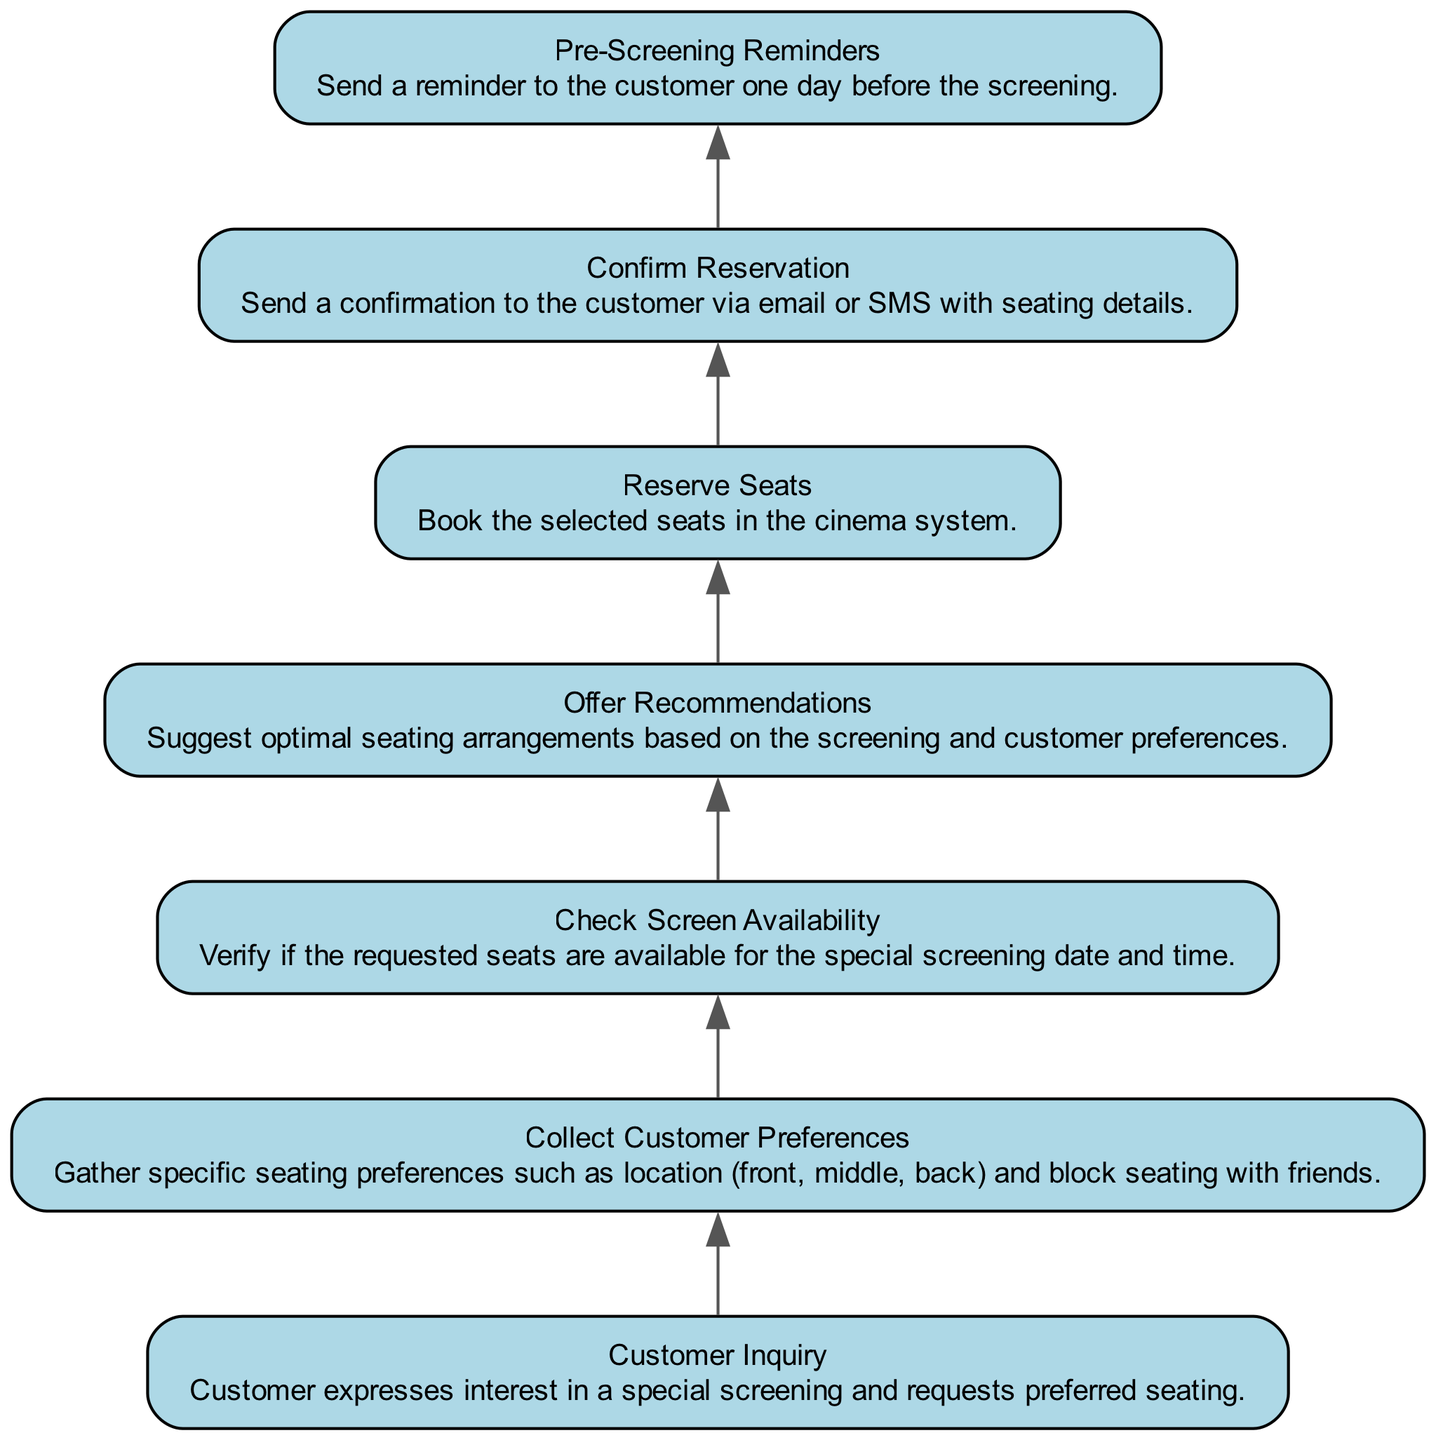What is the first step in the seat reservation process? The first step shown in the diagram is "Customer Inquiry," where the customer expresses their interest in a special screening.
Answer: Customer Inquiry How many nodes are presented in the diagram? Upon counting the nodes listed in the diagram, there are a total of 7 nodes that represent different steps in the reservation process.
Answer: 7 What do customers do after expressing their interest in a special screening? After the "Customer Inquiry" step, the next action taken is to "Collect Customer Preferences" for seating arrangements.
Answer: Collect Customer Preferences What is the last step in the seat reservation process? The last step shown in the diagram is "Pre-Screening Reminders," where a reminder is sent to the customer one day before the screening.
Answer: Pre-Screening Reminders Which node follows the "Check Screen Availability" node? Following "Check Screen Availability," the next step in the process is "Offer Recommendations," suggesting suitable seating options based on preferences.
Answer: Offer Recommendations How does the process flow from "Reserve Seats" to "Confirm Reservation"? Once the seats are reserved in the "Reserve Seats" step, the next step is to "Confirm Reservation," where a confirmation is sent to the customer.
Answer: Confirm Reservation What is the relationship between "Collect Customer Preferences" and "Check Screen Availability"? "Collect Customer Preferences" is the step where preferences are gathered, which leads directly to the subsequent step "Check Screen Availability."
Answer: Sequential Which step includes sending a reminder? The step that involves sending a reminder is "Pre-Screening Reminders," which occurs after the confirmation of reservation is sent to the customer.
Answer: Pre-Screening Reminders 